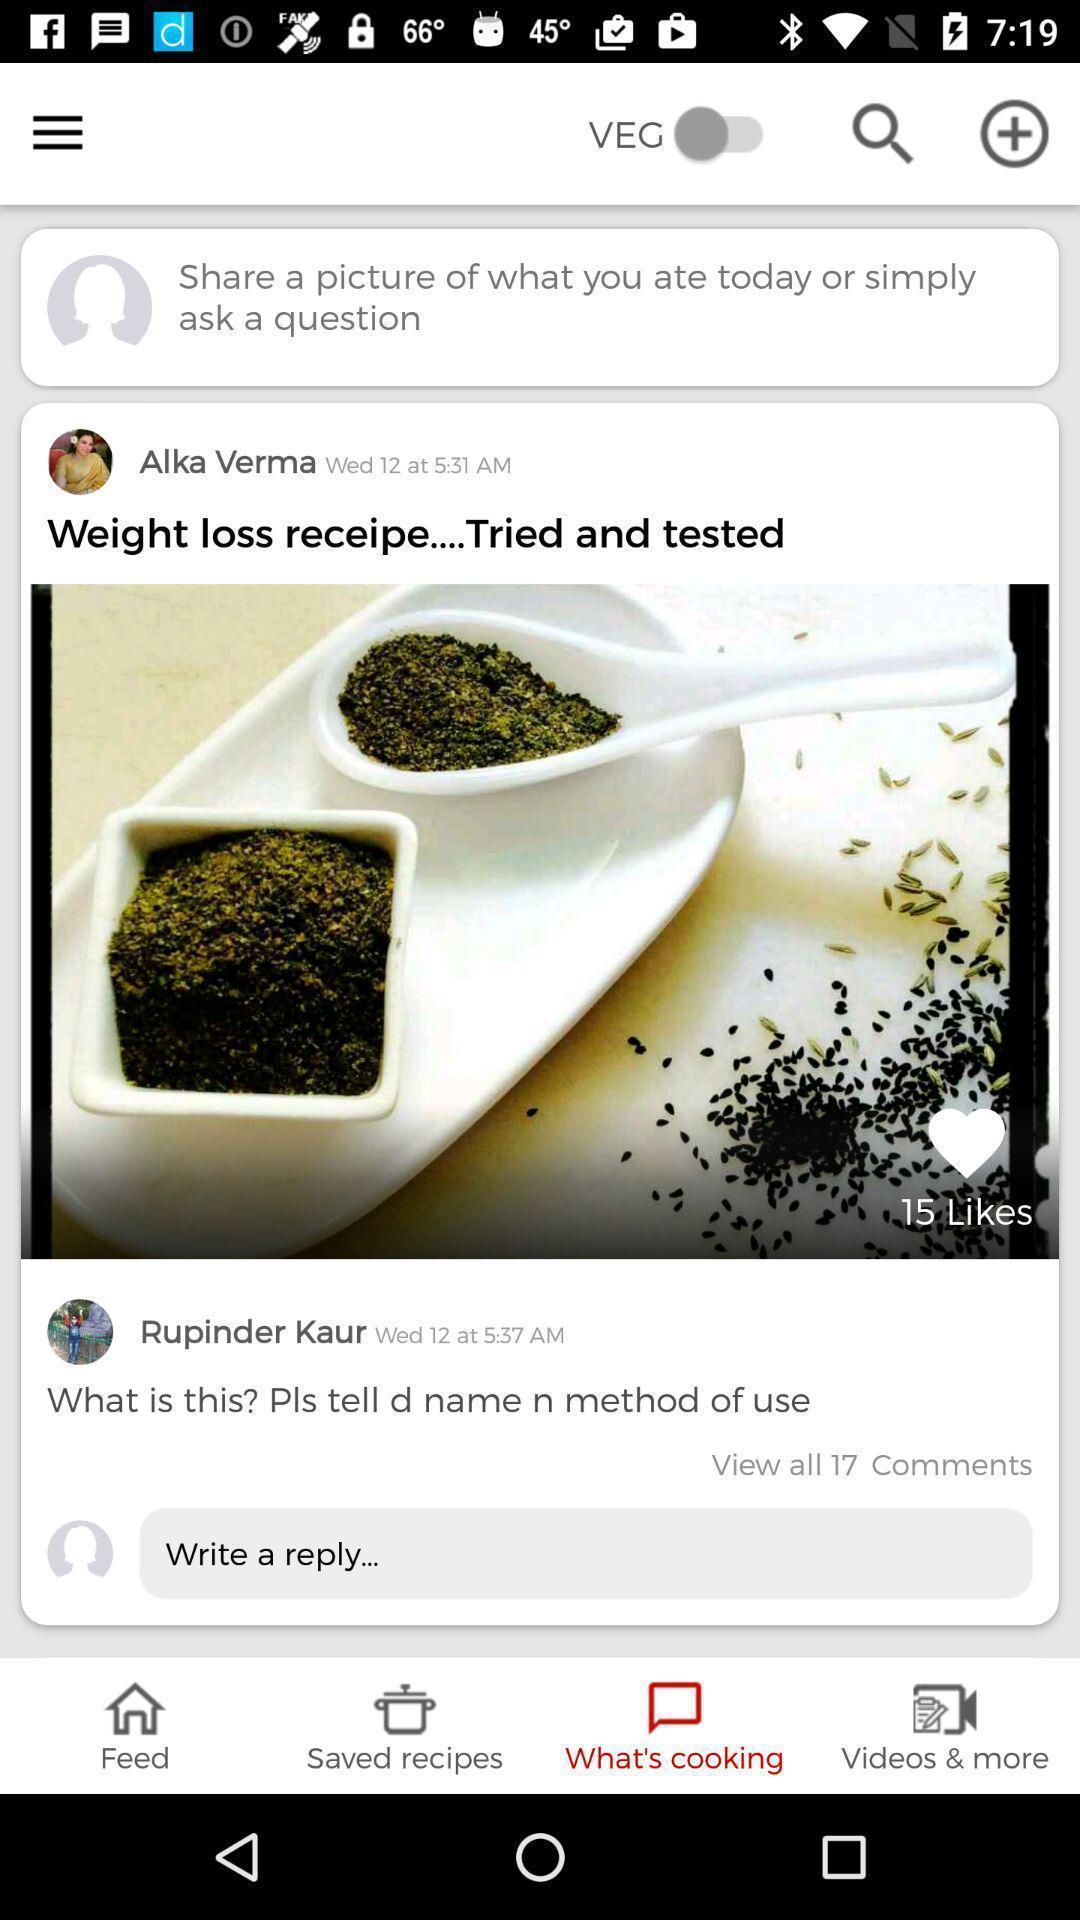Please provide a description for this image. Screen page showing various options. 